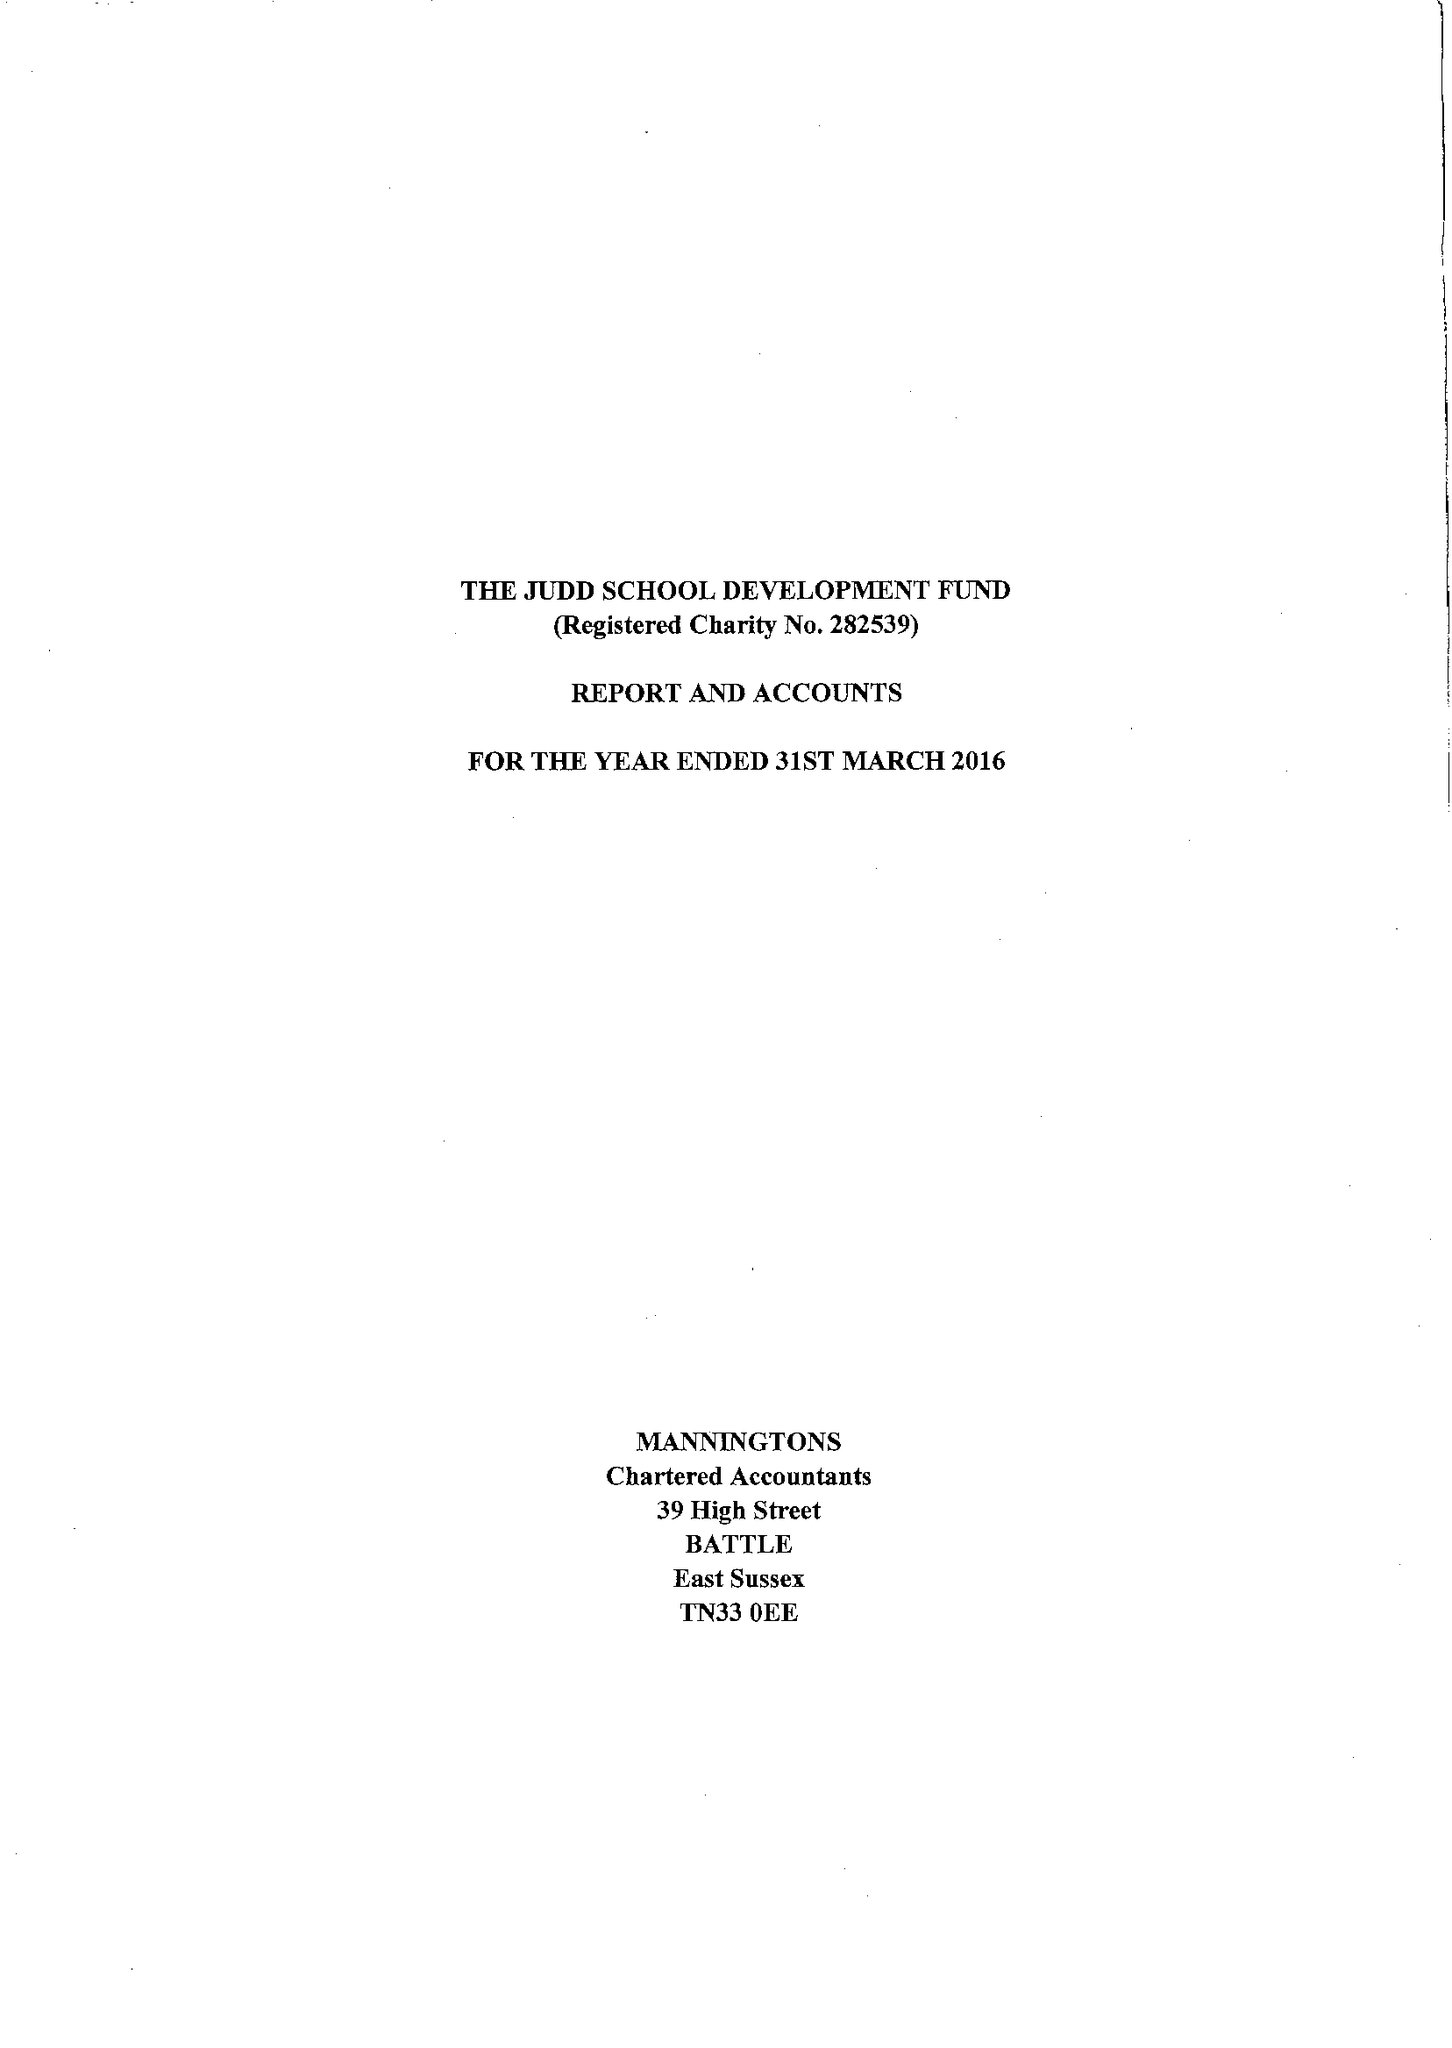What is the value for the charity_name?
Answer the question using a single word or phrase. The Judd School Development Fund 